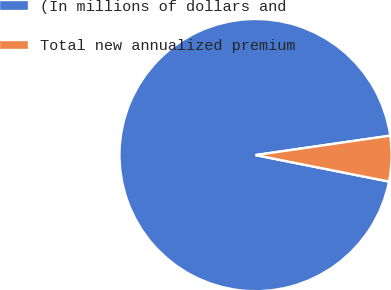Convert chart to OTSL. <chart><loc_0><loc_0><loc_500><loc_500><pie_chart><fcel>(In millions of dollars and<fcel>Total new annualized premium<nl><fcel>94.6%<fcel>5.4%<nl></chart> 